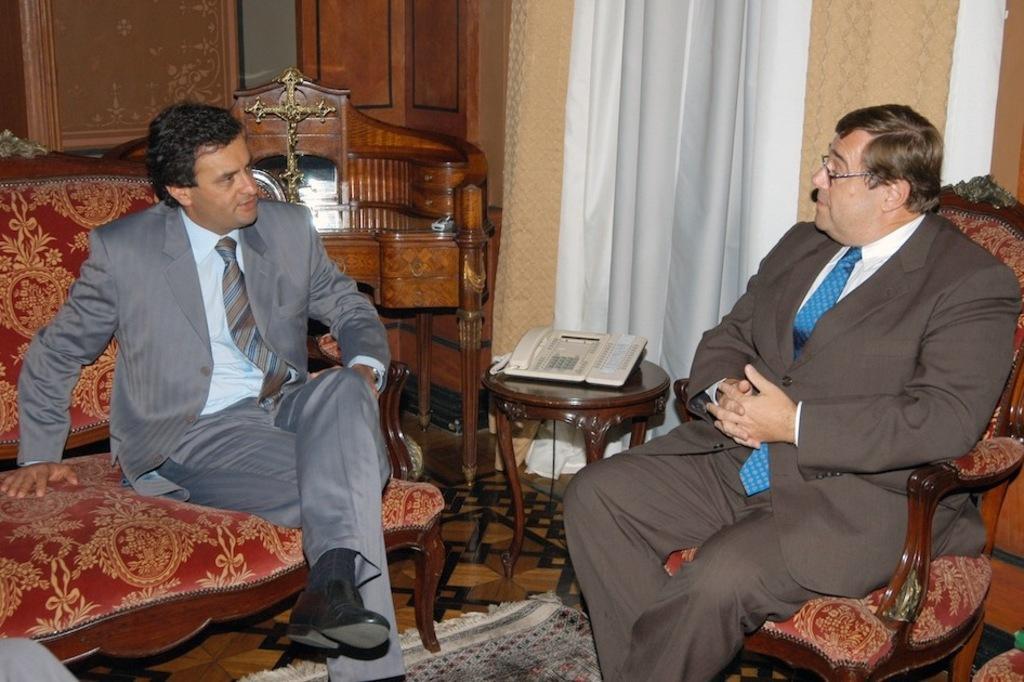How would you summarize this image in a sentence or two? In the picture there are two men sitting on the sofa beside each other near to them there is a table on a table there is a landline phone near to the table there is a curtain on the wall on the floor there is a mat. 